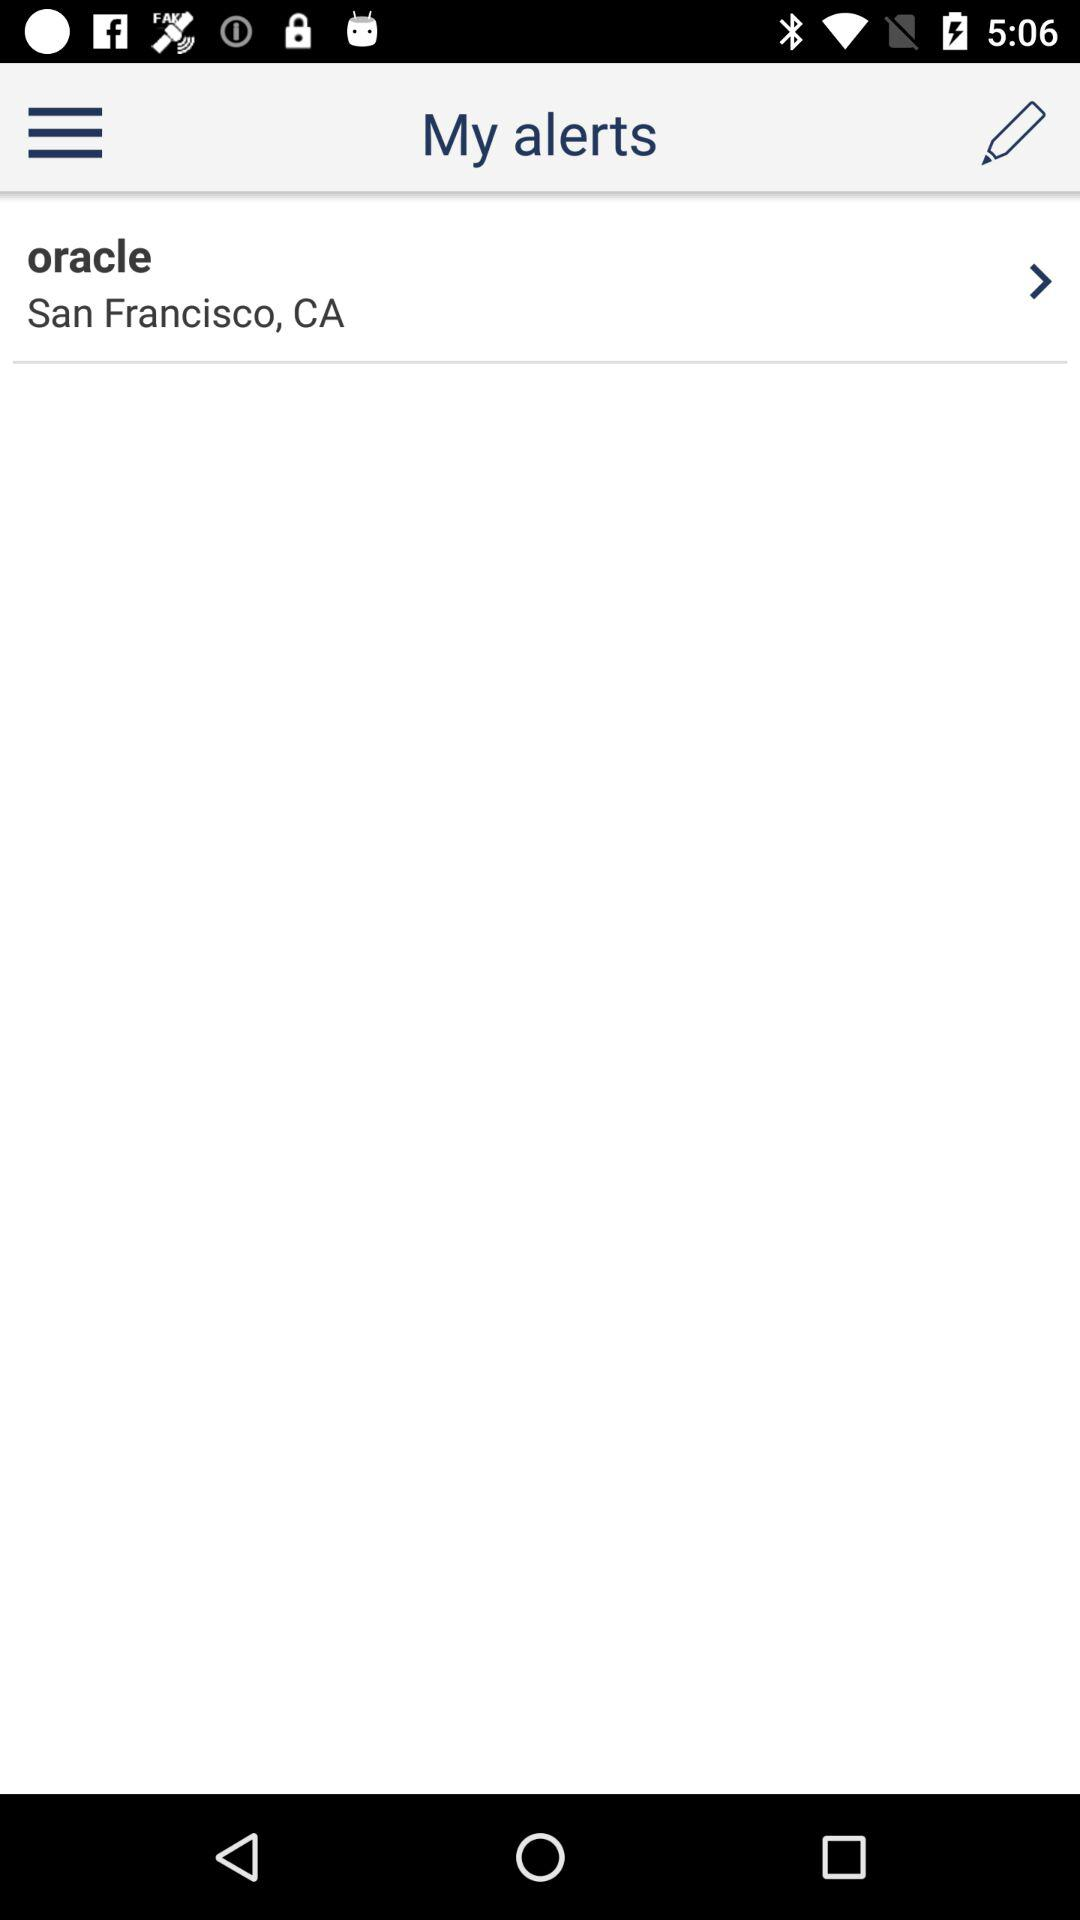What is the location of Oracle? The location is San Francisco, CA. 